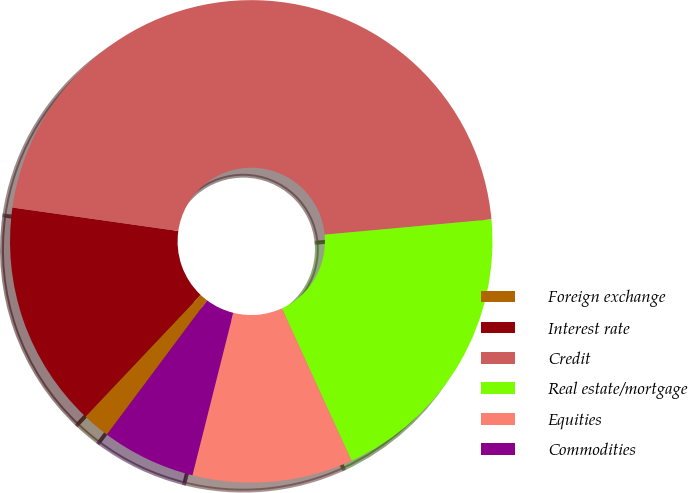<chart> <loc_0><loc_0><loc_500><loc_500><pie_chart><fcel>Foreign exchange<fcel>Interest rate<fcel>Credit<fcel>Real estate/mortgage<fcel>Equities<fcel>Commodities<nl><fcel>1.85%<fcel>15.18%<fcel>46.31%<fcel>19.63%<fcel>10.74%<fcel>6.29%<nl></chart> 